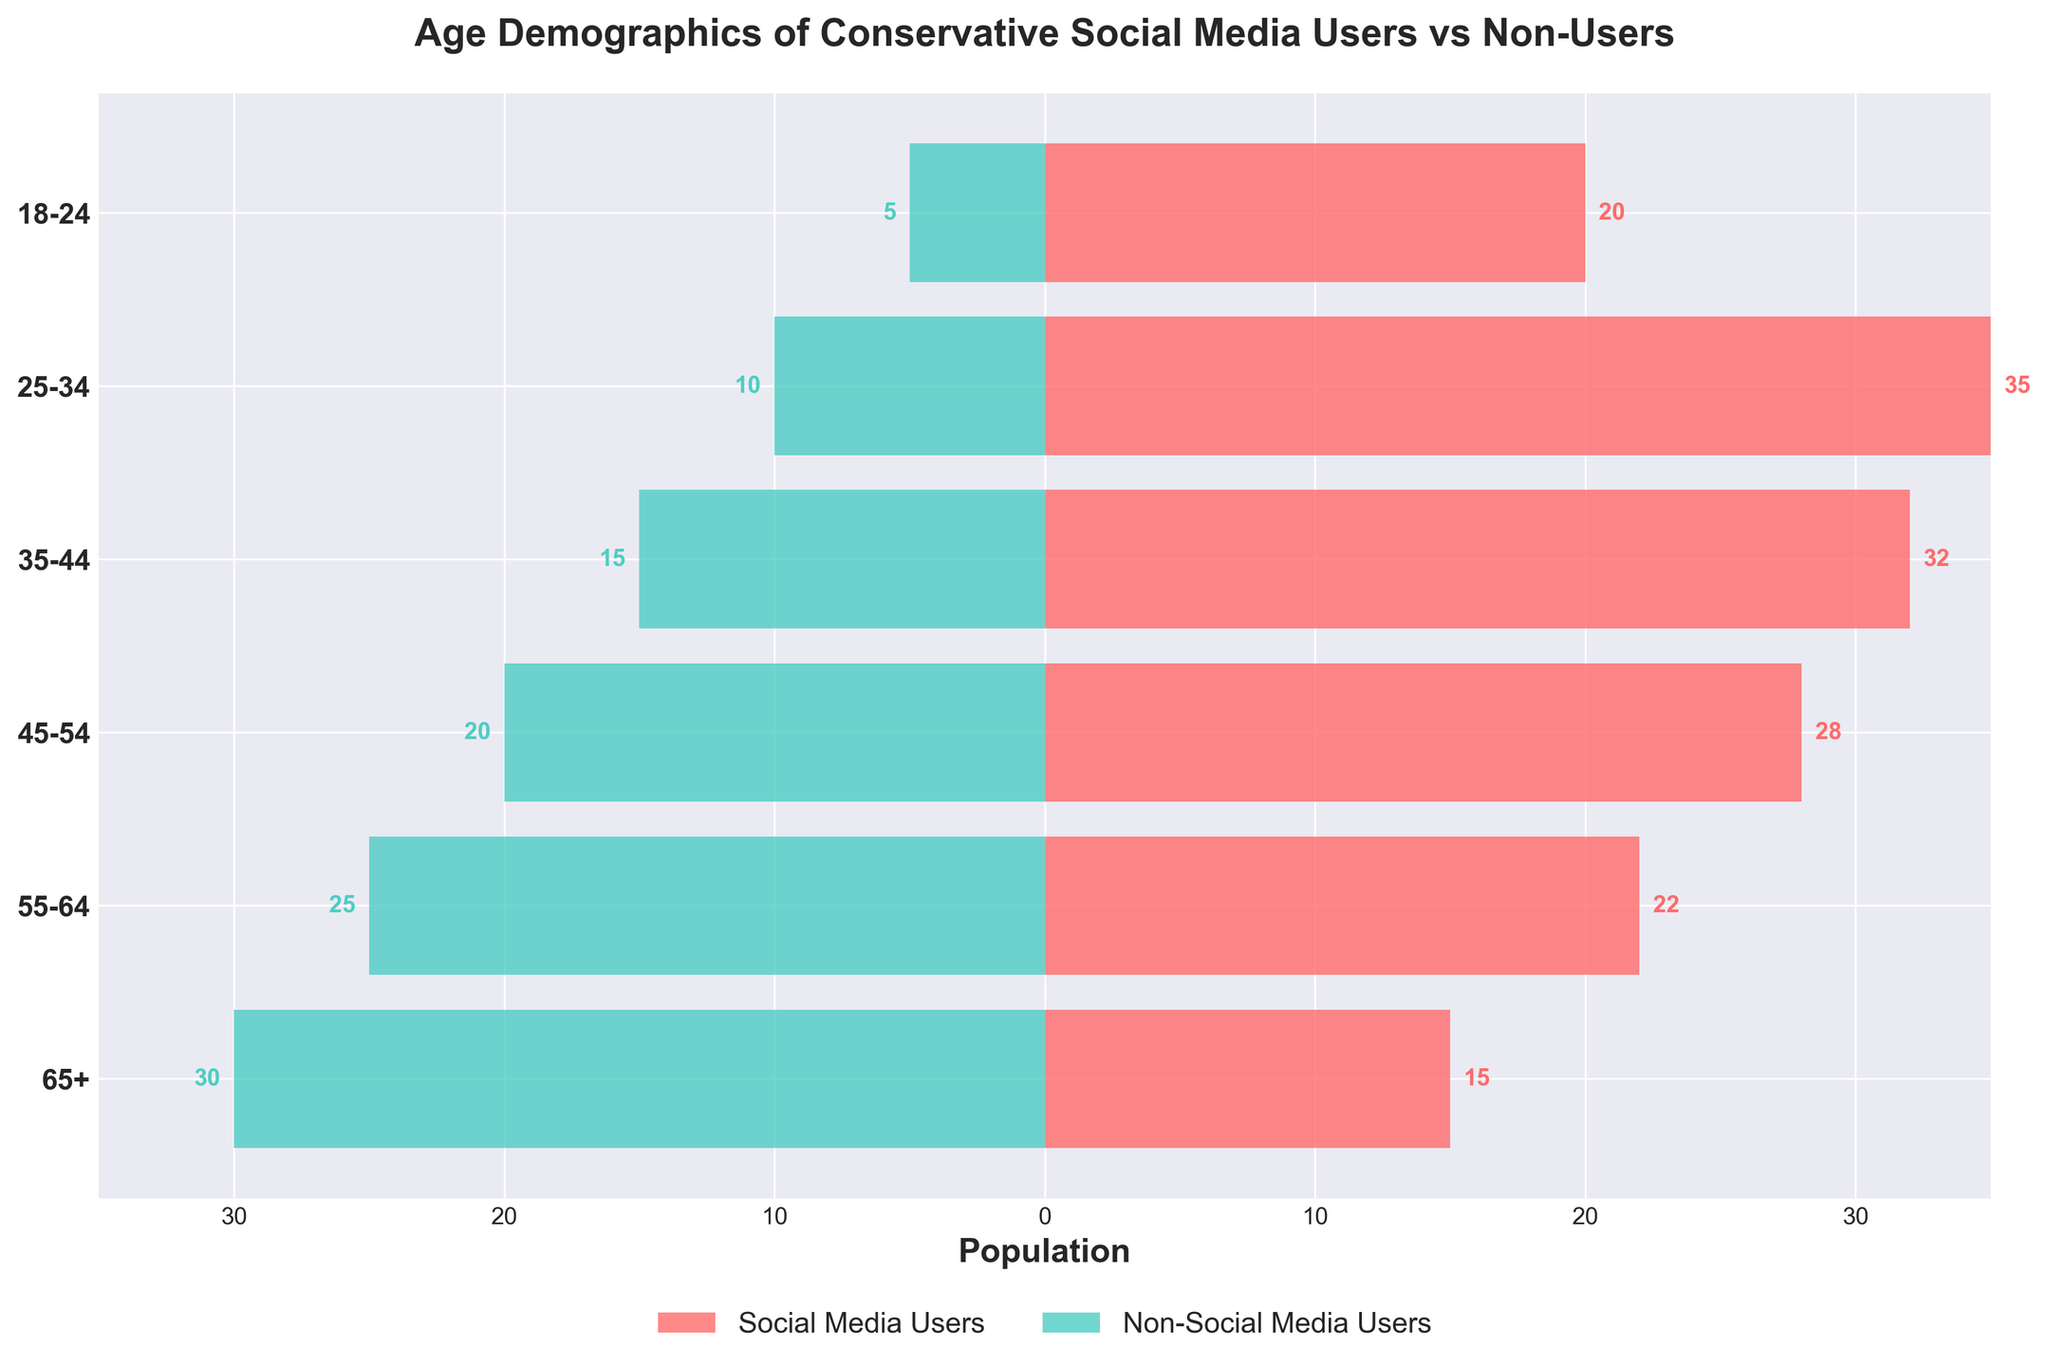What is the title of the figure? The title can be found at the top of the figure. It is written in larger, bold text to indicate what the plot is about.
Answer: Age Demographics of Conservative Social Media Users vs Non-Users What is the age group with the highest number of social media users? Look at the horizontal bars representing social media users, identified by the color. The group with the longest bar has the highest number.
Answer: 25-34 Which age group has the smallest difference between social media users and non-users? Calculate the difference between the number of users and non-users for each age group and identify the smallest difference.
Answer: 55-64 How many social media users are there in the 45-54 age group? Find the horizontal bar corresponding to the 45-54 age group and read the value from the axis.
Answer: 28 What is the total number of non-social media users aged 55+? Add the numbers of non-social media users in the age groups 55-64 and 65+.
Answer: 25 + 30 = 55 In which age group is the number of social media users less than the number of non-social media users? Compare the lengths of bars for users and non-users in each age group to find where the user bar is shorter.
Answer: 65+ What is the combined population of social media and non-social media users in the 18-24 age group? Add the number of social media users to the number of non-social media users in this age group.
Answer: 20 + 5 = 25 Which age group has the largest overall population of conservatives? Add the social media users and non-users for each age group and determine which sum is the largest.
Answer: 25-34 What color represents conservative social media users in the plot? Identify the color used for the horizontal bars representing social media users.
Answer: Red Which age group has the highest total population when combining both social media and non-social media users? Add the values for each age group and find the age group with the highest total.
Answer: 25-34 